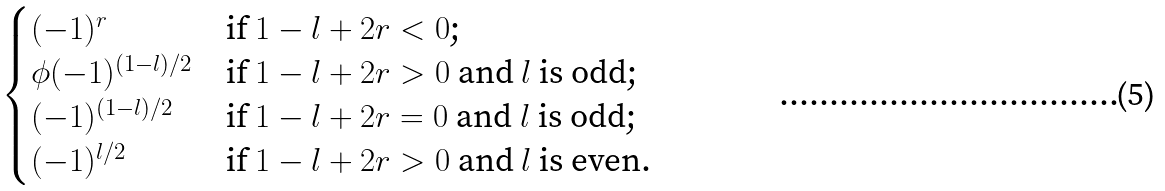Convert formula to latex. <formula><loc_0><loc_0><loc_500><loc_500>\begin{cases} ( - 1 ) ^ { r } & \text {if $1-l+2r < 0$;} \\ \phi ( - 1 ) ^ { ( 1 - l ) / 2 } & \text {if $1-l+2r > 0$ and $l$ is odd;} \\ ( - 1 ) ^ { ( 1 - l ) / 2 } & \text {if $1-l+2r = 0$ and $l$ is odd;} \\ ( - 1 ) ^ { l / 2 } & \text {if $1-l+2r > 0$ and $l$ is even.} \end{cases}</formula> 